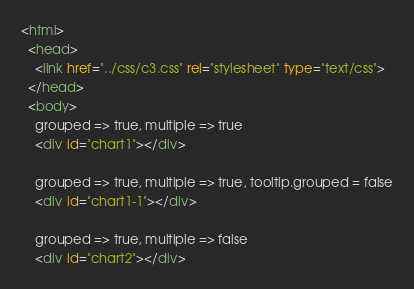Convert code to text. <code><loc_0><loc_0><loc_500><loc_500><_HTML_><html>
  <head>
    <link href="../css/c3.css" rel="stylesheet" type="text/css">
  </head>
  <body>
    grouped => true, multiple => true
    <div id="chart1"></div>

    grouped => true, multiple => true, tooltip.grouped = false
    <div id="chart1-1"></div>

    grouped => true, multiple => false
    <div id="chart2"></div>
</code> 